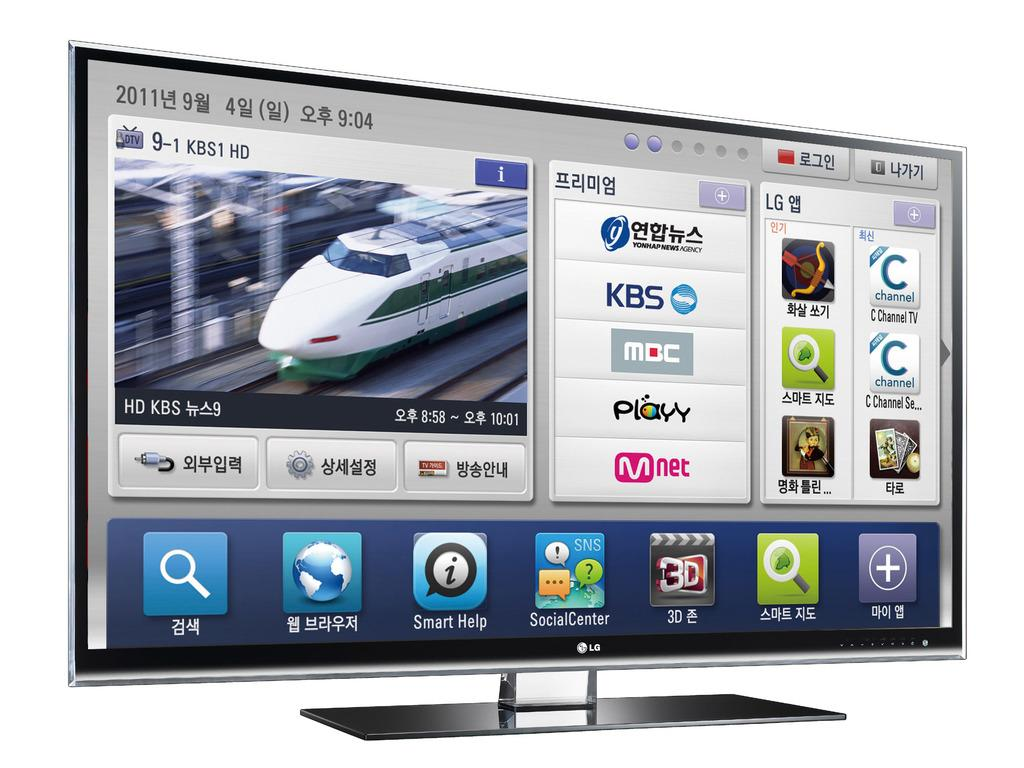<image>
Share a concise interpretation of the image provided. Computer screen displaying Your app/news agency showing KBS and Mnet. 